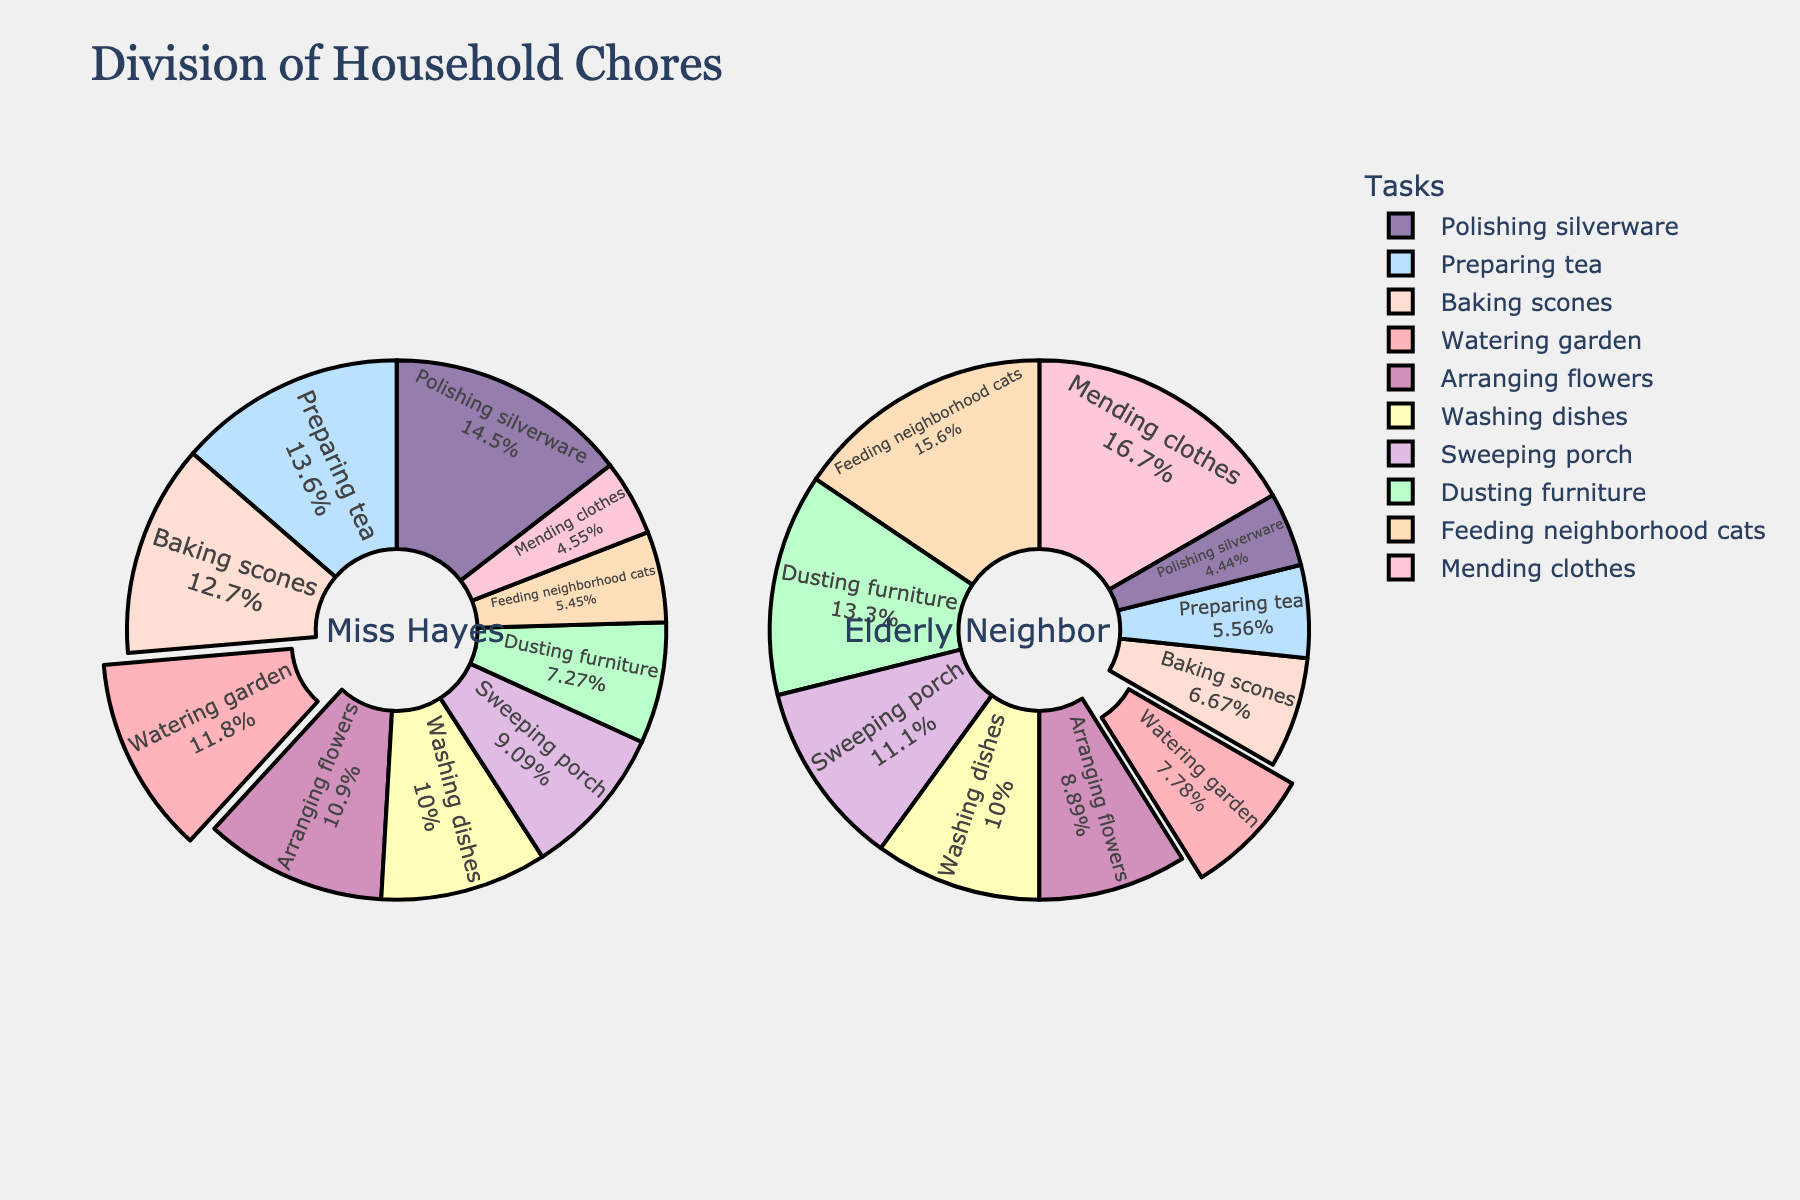What percentage of chores does Miss Hayes handle for watering the garden? The figure shows separate pie charts for Miss Hayes and her elderly neighbor. In the pie chart for Miss Hayes, the slice corresponding to watering garden is represented as 65% of the entire pie.
Answer: 65% Who does more of the dusting chores? By referring to the pie charts, we see that the slice for dusting furniture is 40% in Miss Hayes's chart and 60% in the elderly neighbor's chart, indicating the elderly neighbor does more.
Answer: Elderly Neighbor Between preparing tea and washing dishes, which task does Miss Hayes take on more? The slice for preparing tea in Miss Hayes's pie chart is 75%, while the slice for washing dishes is 55%. This shows Miss Hayes takes on more of the task of preparing tea.
Answer: Preparing tea What percentage of polishing silverware does the elderly neighbor handle? Looking at the pie chart for the elderly neighbor, the slice for polishing silverware is 20%.
Answer: 20% Combine the shares of feeding neighborhood cats and mending clothes done by the elderly neighbor. What is the total percentage? In the pie chart for the elderly neighbor, the slice for feeding neighborhood cats is 70% and for mending clothes is 75%. Adding these gives 70% + 75% = 145%.
Answer: 145% Which task is equally shared between Miss Hayes and the elderly neighbor? From the pie charts, we see that the task of sweeping porch has slices of 50% in both Miss Hayes's and the elderly neighbor's charts, indicating it is equally shared.
Answer: Sweeping porch Compare who is responsible for a higher percentage of arranging flowers and by how much. The pie chart for Miss Hayes shows she handles 60% of arranging flowers, while the elderly neighbor handles 40%. Thus, Miss Hayes is responsible for 20% more.
Answer: Miss Hayes, 20% Name the task that has the highest percentage in Miss Hayes’s pie chart. By comparing the different slices in Miss Hayes’s pie chart, the task "polishing silverware" has the highest percentage at 80%.
Answer: Polishing silverware Sum up the percentages of tasks where Miss Hayes handles more than her neighbor and determine the total. Miss Hayes handles more of watering garden (65%), preparing tea (75%), washing dishes (55%), polishing silverware (80%), arranging flowers (60%), and baking scones (70%). Summing these: 65% + 75% + 55% + 80% + 60% + 70% = 405%.
Answer: 405% What color is used to represent the "baking scones" task in both pie charts? The pie chart features distinct colors for each task. The slice corresponding to baking scones is colored light pink.
Answer: Light pink 